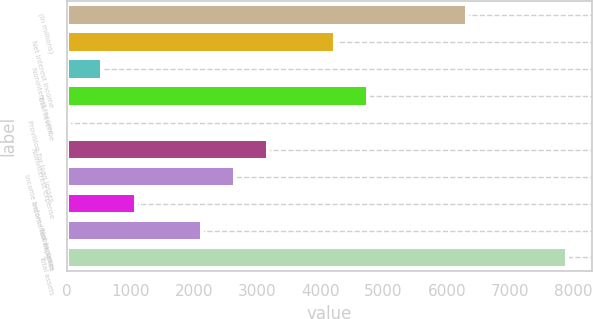<chart> <loc_0><loc_0><loc_500><loc_500><bar_chart><fcel>(In millions)<fcel>Net interest income<fcel>Noninterest income<fcel>Total revenue<fcel>Provision for loan losses<fcel>Noninterest expense<fcel>Income before income taxes<fcel>Income tax expense<fcel>Net income<fcel>Total assets<nl><fcel>6328.7<fcel>4229.3<fcel>555.35<fcel>4754.15<fcel>30.5<fcel>3179.6<fcel>2654.75<fcel>1080.2<fcel>2129.9<fcel>7903.25<nl></chart> 